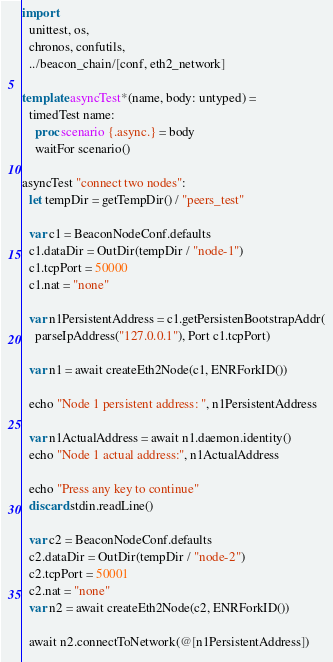<code> <loc_0><loc_0><loc_500><loc_500><_Nim_>import
  unittest, os,
  chronos, confutils,
  ../beacon_chain/[conf, eth2_network]

template asyncTest*(name, body: untyped) =
  timedTest name:
    proc scenario {.async.} = body
    waitFor scenario()

asyncTest "connect two nodes":
  let tempDir = getTempDir() / "peers_test"

  var c1 = BeaconNodeConf.defaults
  c1.dataDir = OutDir(tempDir / "node-1")
  c1.tcpPort = 50000
  c1.nat = "none"

  var n1PersistentAddress = c1.getPersistenBootstrapAddr(
    parseIpAddress("127.0.0.1"), Port c1.tcpPort)

  var n1 = await createEth2Node(c1, ENRForkID())

  echo "Node 1 persistent address: ", n1PersistentAddress

  var n1ActualAddress = await n1.daemon.identity()
  echo "Node 1 actual address:", n1ActualAddress

  echo "Press any key to continue"
  discard stdin.readLine()

  var c2 = BeaconNodeConf.defaults
  c2.dataDir = OutDir(tempDir / "node-2")
  c2.tcpPort = 50001
  c2.nat = "none"
  var n2 = await createEth2Node(c2, ENRForkID())

  await n2.connectToNetwork(@[n1PersistentAddress])

</code> 